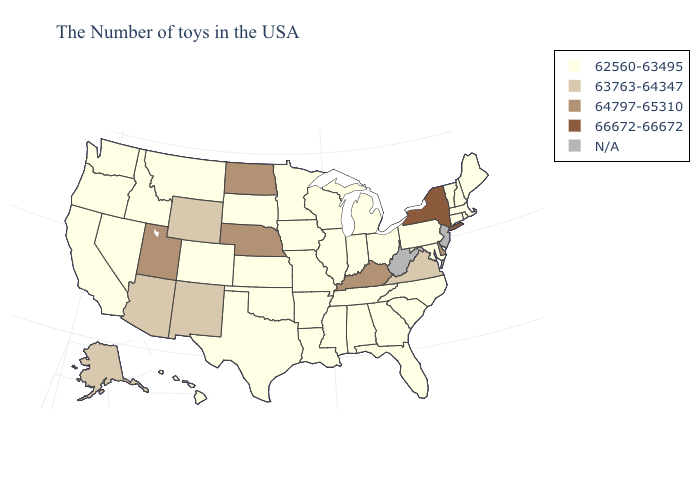Does North Carolina have the highest value in the USA?
Answer briefly. No. Name the states that have a value in the range N/A?
Keep it brief. New Jersey, West Virginia. Does Mississippi have the highest value in the USA?
Give a very brief answer. No. Name the states that have a value in the range 64797-65310?
Answer briefly. Delaware, Kentucky, Nebraska, North Dakota, Utah. What is the lowest value in the Northeast?
Be succinct. 62560-63495. Does the first symbol in the legend represent the smallest category?
Concise answer only. Yes. Name the states that have a value in the range 63763-64347?
Be succinct. Virginia, Wyoming, New Mexico, Arizona, Alaska. Name the states that have a value in the range 64797-65310?
Answer briefly. Delaware, Kentucky, Nebraska, North Dakota, Utah. What is the lowest value in the Northeast?
Short answer required. 62560-63495. Among the states that border Nevada , does Utah have the lowest value?
Keep it brief. No. Name the states that have a value in the range 63763-64347?
Give a very brief answer. Virginia, Wyoming, New Mexico, Arizona, Alaska. Does New York have the highest value in the Northeast?
Quick response, please. Yes. What is the value of Nevada?
Be succinct. 62560-63495. Does Massachusetts have the highest value in the Northeast?
Keep it brief. No. 